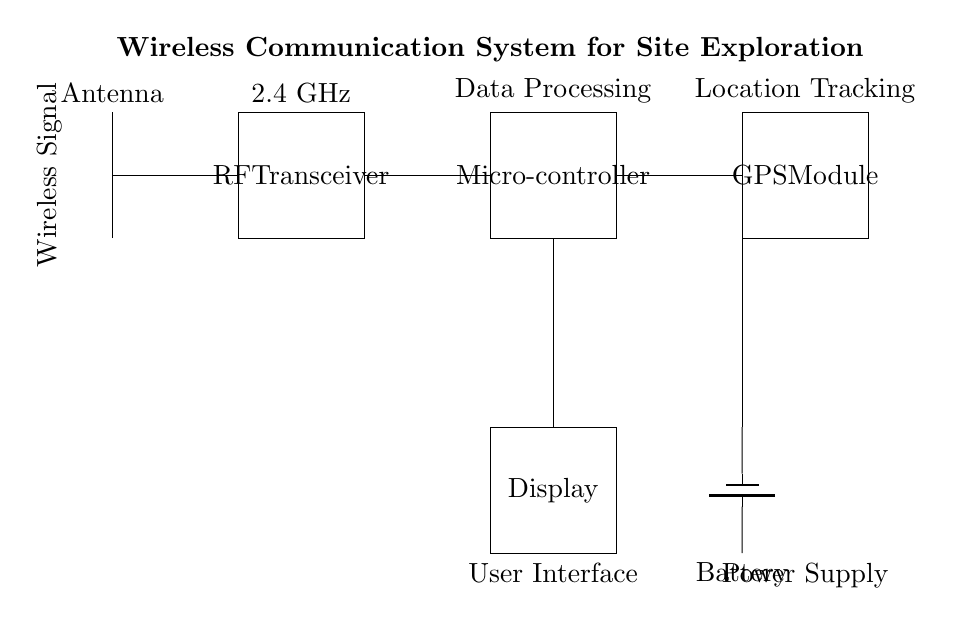what is the primary function of the RF transceiver? The RF transceiver is responsible for sending and receiving wireless signals at a frequency of 2.4 GHz, enabling communication between the devices.
Answer: communication what component powers the system? The battery is identified as the power supply component, which provides the necessary energy for the entire circuit to function.
Answer: battery how many main components are shown in the circuit? There are five main components indicated: Antenna, RF Transceiver, Microcontroller, GPS Module, and Display, which collectively make up the system.
Answer: five what is the display used for? The display serves as the user interface, allowing users to view information and statuses of the system in real-time during exploration.
Answer: user interface which component is responsible for location tracking? The GPS Module is specifically designed for location tracking, providing positional data that can be essential for navigation during site explorations.
Answer: GPS Module how does the microcontroller contribute to the system? The microcontroller is essential for data processing, receiving inputs from the RF Transceiver and GPS Module, and controlling the overall operation of the communication system.
Answer: data processing what type of signal does the antenna transmit? The antenna transmits a wireless signal characteristic of the 2.4 GHz frequency band, which is commonly used for various wireless communications.
Answer: wireless signal 